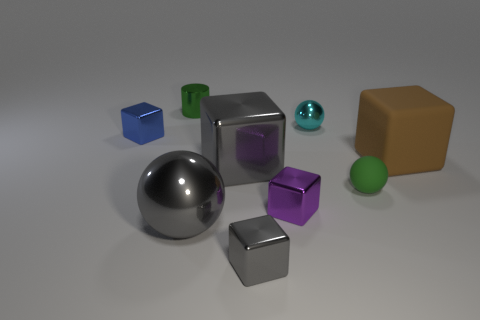What material is the large thing that is the same color as the big metal ball?
Ensure brevity in your answer.  Metal. How many metal spheres have the same color as the small shiny cylinder?
Provide a succinct answer. 0. The other small thing that is the same shape as the cyan thing is what color?
Offer a very short reply. Green. There is a large thing that is both on the left side of the small cyan object and behind the gray sphere; what shape is it?
Ensure brevity in your answer.  Cube. Are there more tiny gray shiny cubes than small balls?
Ensure brevity in your answer.  No. What is the green ball made of?
Your answer should be very brief. Rubber. There is a gray shiny thing that is the same shape as the tiny rubber thing; what size is it?
Provide a short and direct response. Large. There is a green object that is to the left of the cyan object; are there any tiny things that are on the right side of it?
Offer a terse response. Yes. Do the small matte sphere and the metallic cylinder have the same color?
Ensure brevity in your answer.  Yes. What number of other things are there of the same shape as the tiny gray metallic object?
Make the answer very short. 4. 